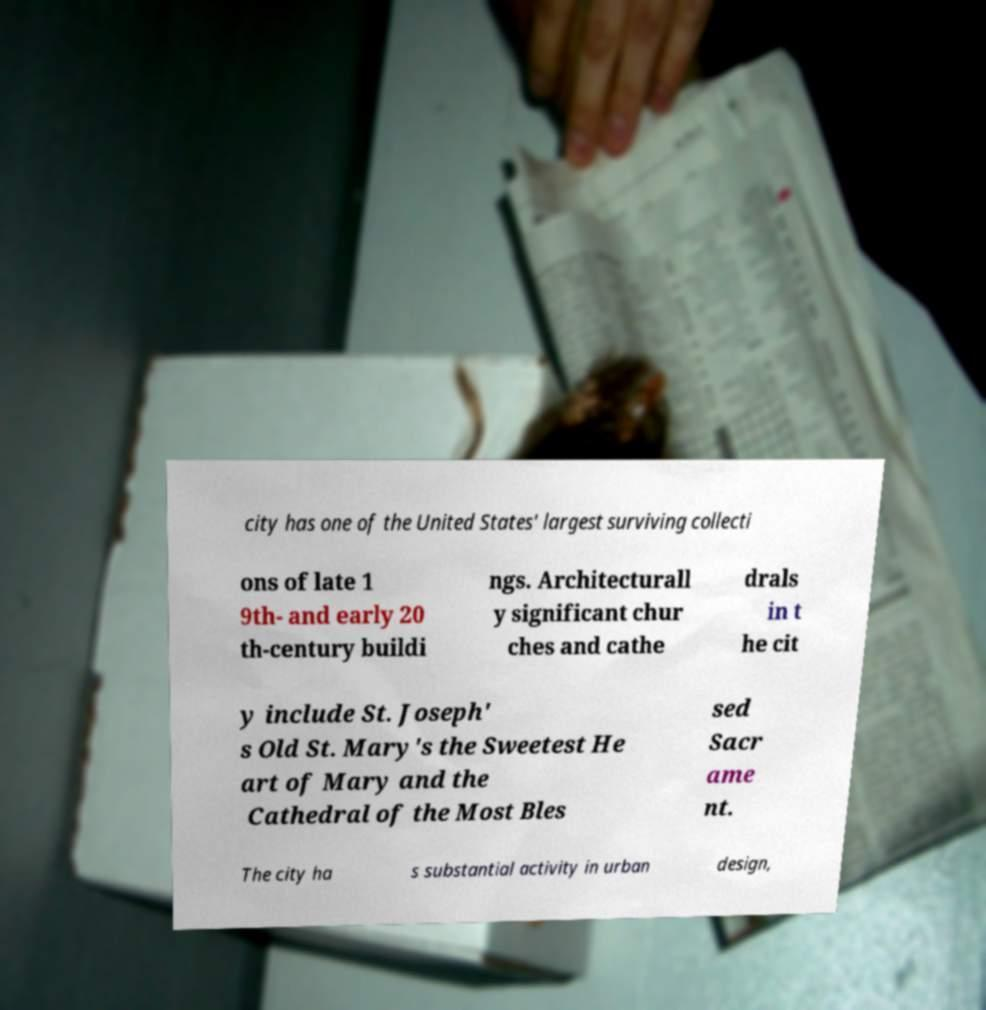There's text embedded in this image that I need extracted. Can you transcribe it verbatim? city has one of the United States' largest surviving collecti ons of late 1 9th- and early 20 th-century buildi ngs. Architecturall y significant chur ches and cathe drals in t he cit y include St. Joseph' s Old St. Mary's the Sweetest He art of Mary and the Cathedral of the Most Bles sed Sacr ame nt. The city ha s substantial activity in urban design, 